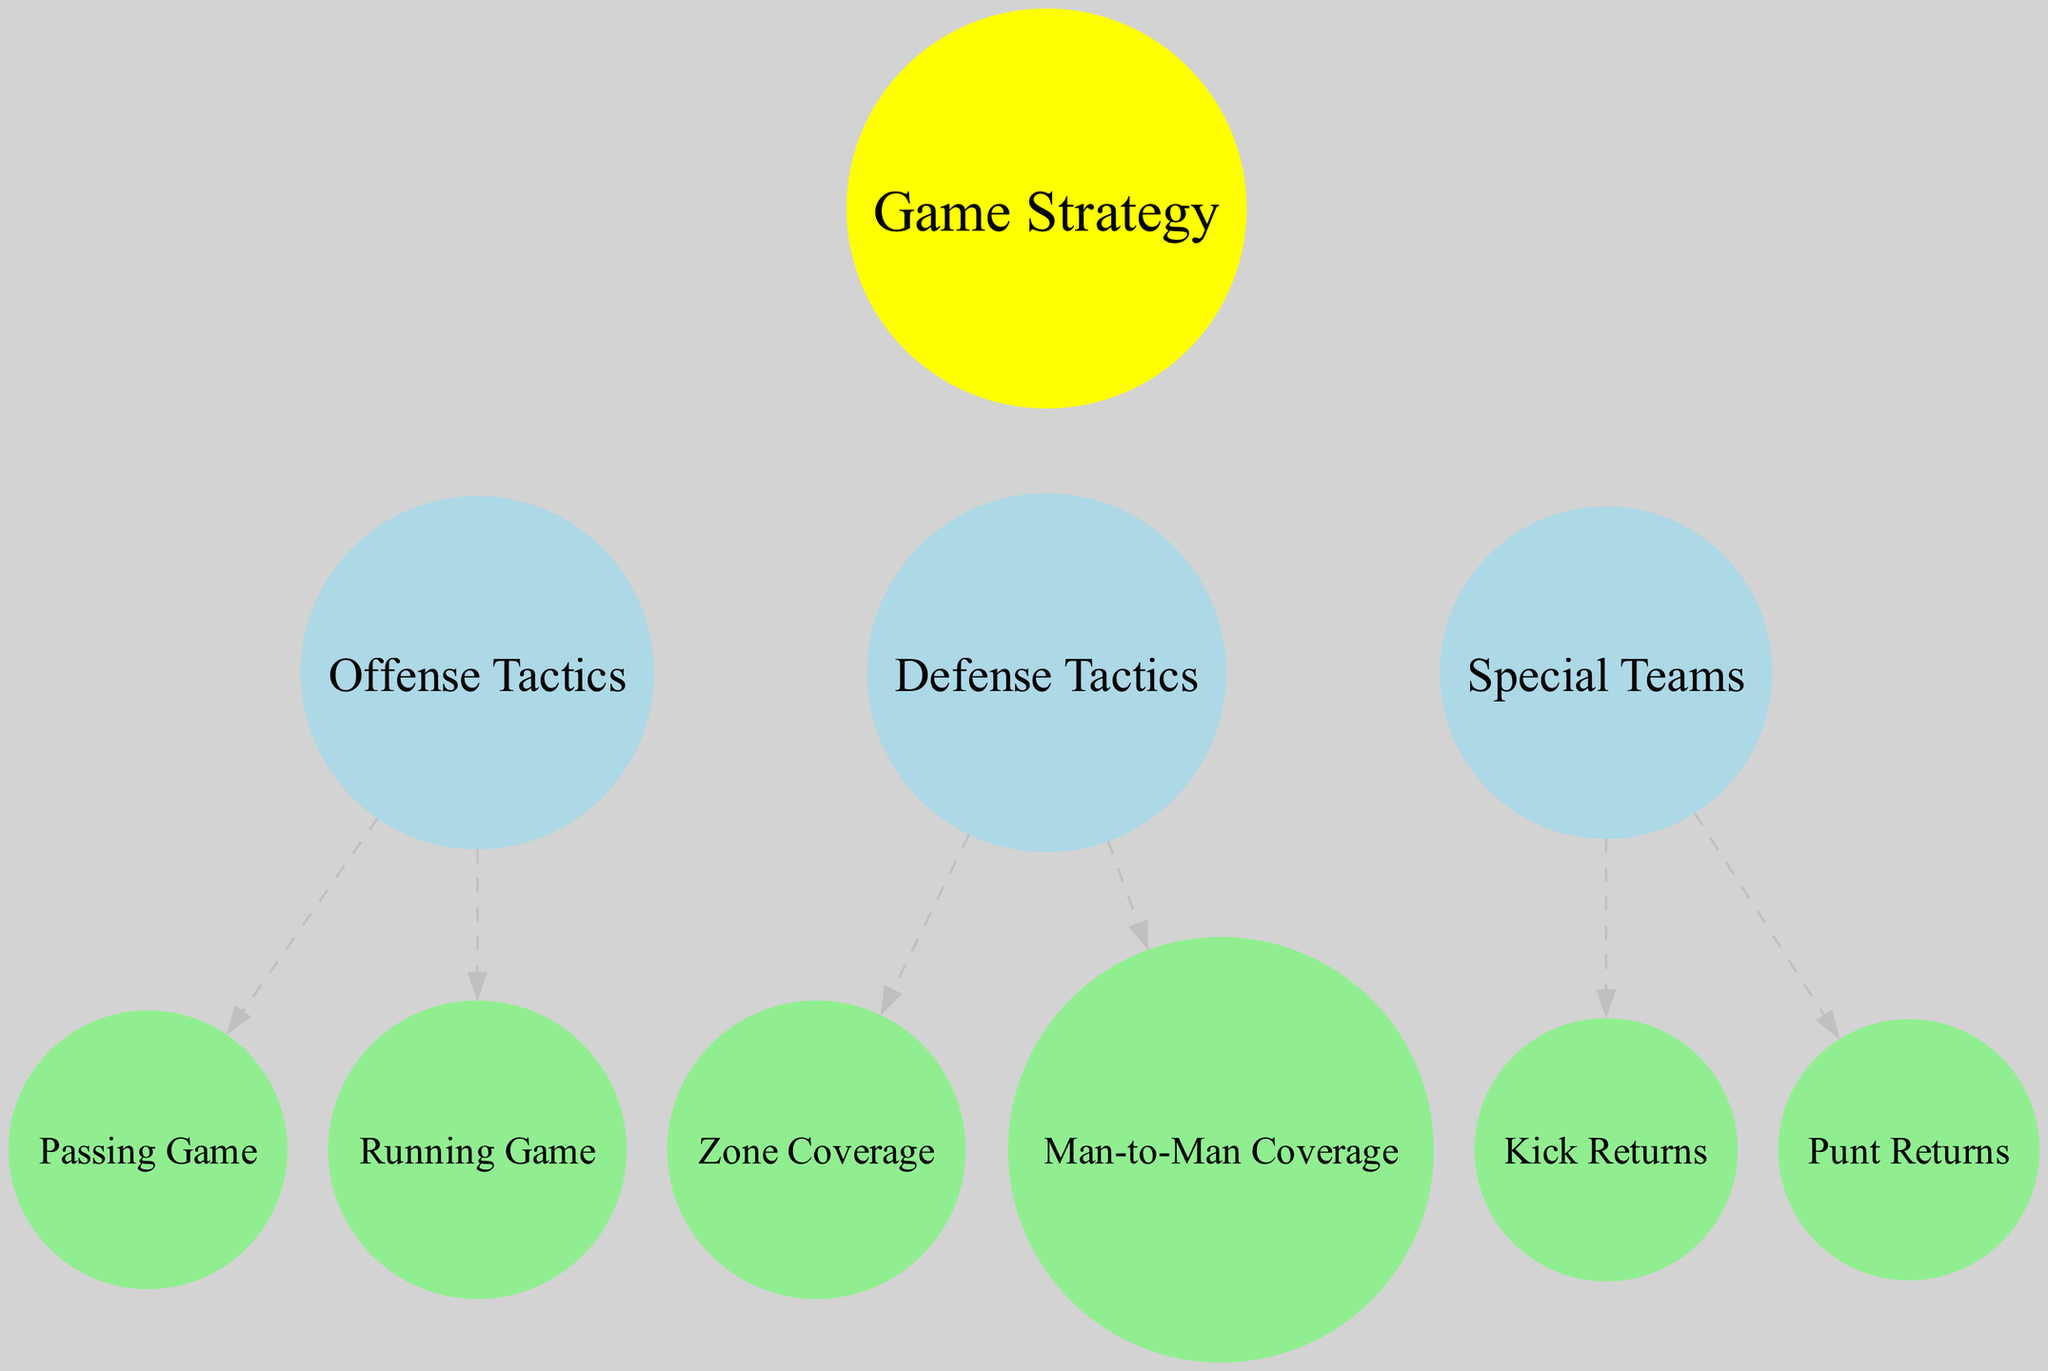What is the central concept represented in the diagram? The diagram focuses on "Game Strategy" which is depicted as the sun at the center. This central node represents the guiding principle of the team.
Answer: Game Strategy How many planets are represented in the diagram? There are three distinct planets that correspond to different categories of game tactics. These are "Offense Tactics," "Defense Tactics," and "Special Teams."
Answer: 3 What are the two moons associated with "Offense Tactics"? The moons linked to "Offense Tactics" are "Passing Game" which highlights aerial strategies, and "Running Game" which focuses on ground-based plays.
Answer: Passing Game, Running Game Which moon is connected to "Defense Tactics"? The moons related to "Defense Tactics" include "Zone Coverage" and "Man-to-Man Coverage," both of which outline different defensive strategies.
Answer: Zone Coverage, Man-to-Man Coverage What type of plays fall under "Special Teams"? "Special Teams" encompasses plays executed during specific situations such as kickoffs, punts, and field goals, indicating its focus on specialized game scenarios.
Answer: Specialized plays Which planet has the most moons? Each planet in the diagram has two moons, resulting in an equal distribution across the three planets—there is no single planet with more moons than the others.
Answer: None (equal) What is the color of the nodes representing the moons? The moons are depicted in light green, differentiating them from the planets and the central sun.
Answer: Light green What does "Zone Coverage" imply in terms of defensive strategy? "Zone Coverage" indicates that defenders are assigned to cover specific areas on the field rather than focusing on individual players, reflecting a systematic defensive approach.
Answer: Area coverage Which strategy focuses exclusively on receiving and running back kickoffs? The strategy aimed specifically at receiving and returning kickoffs is referred to as "Kick Returns," part of the "Special Teams" tactics.
Answer: Kick Returns 